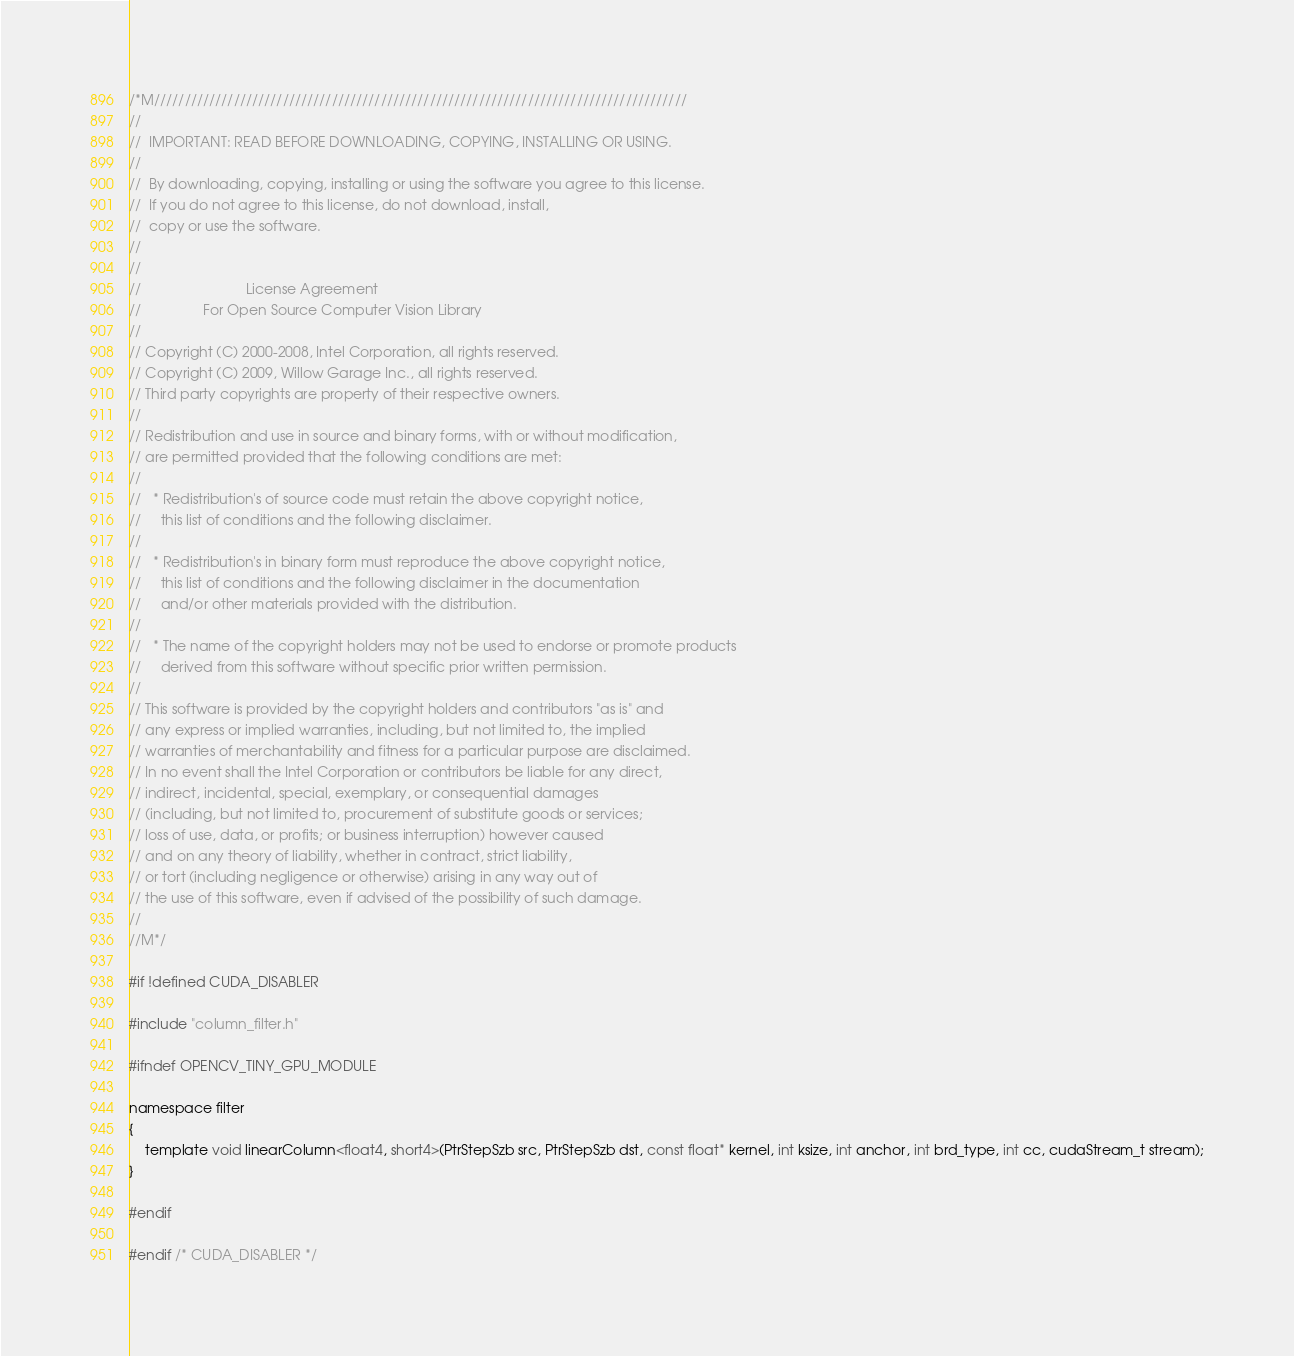<code> <loc_0><loc_0><loc_500><loc_500><_Cuda_>/*M///////////////////////////////////////////////////////////////////////////////////////
//
//  IMPORTANT: READ BEFORE DOWNLOADING, COPYING, INSTALLING OR USING.
//
//  By downloading, copying, installing or using the software you agree to this license.
//  If you do not agree to this license, do not download, install,
//  copy or use the software.
//
//
//                           License Agreement
//                For Open Source Computer Vision Library
//
// Copyright (C) 2000-2008, Intel Corporation, all rights reserved.
// Copyright (C) 2009, Willow Garage Inc., all rights reserved.
// Third party copyrights are property of their respective owners.
//
// Redistribution and use in source and binary forms, with or without modification,
// are permitted provided that the following conditions are met:
//
//   * Redistribution's of source code must retain the above copyright notice,
//     this list of conditions and the following disclaimer.
//
//   * Redistribution's in binary form must reproduce the above copyright notice,
//     this list of conditions and the following disclaimer in the documentation
//     and/or other materials provided with the distribution.
//
//   * The name of the copyright holders may not be used to endorse or promote products
//     derived from this software without specific prior written permission.
//
// This software is provided by the copyright holders and contributors "as is" and
// any express or implied warranties, including, but not limited to, the implied
// warranties of merchantability and fitness for a particular purpose are disclaimed.
// In no event shall the Intel Corporation or contributors be liable for any direct,
// indirect, incidental, special, exemplary, or consequential damages
// (including, but not limited to, procurement of substitute goods or services;
// loss of use, data, or profits; or business interruption) however caused
// and on any theory of liability, whether in contract, strict liability,
// or tort (including negligence or otherwise) arising in any way out of
// the use of this software, even if advised of the possibility of such damage.
//
//M*/

#if !defined CUDA_DISABLER

#include "column_filter.h"

#ifndef OPENCV_TINY_GPU_MODULE

namespace filter
{
    template void linearColumn<float4, short4>(PtrStepSzb src, PtrStepSzb dst, const float* kernel, int ksize, int anchor, int brd_type, int cc, cudaStream_t stream);
}

#endif

#endif /* CUDA_DISABLER */
</code> 